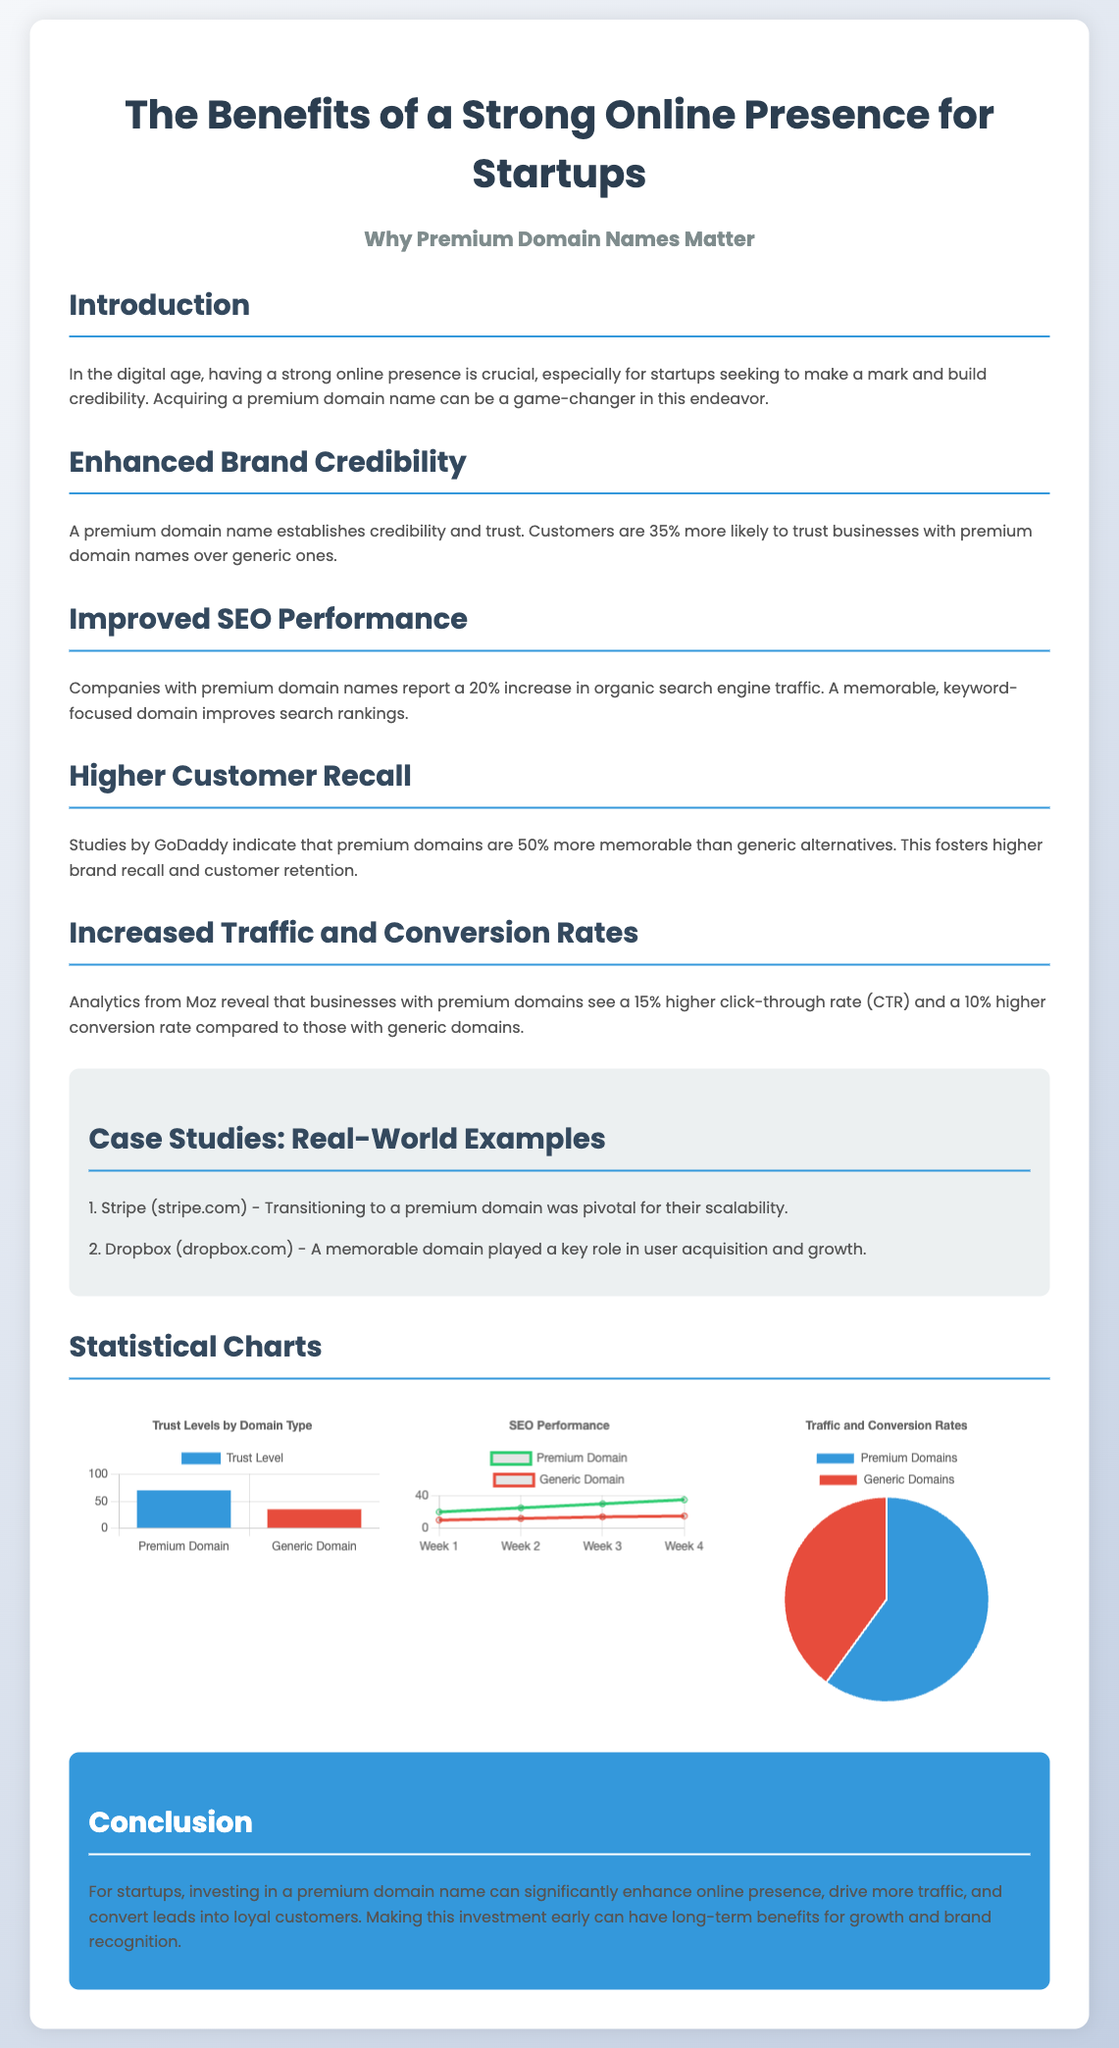What is the trust level for premium domains? The document states that customers are 35% more likely to trust businesses with premium domain names over generic ones, which indicates a trust level of 70% for premium domains.
Answer: 70% What is the trust level for generic domains? The trust level for generic domains is provided in the document as being 35%.
Answer: 35% What percentage increase in organic search engine traffic do premium domains report? The document mentions that companies with premium domain names report a 20% increase in organic search engine traffic.
Answer: 20% What were the SEO performance numbers for generic domains in Week 4? The data for generic domains in Week 4 is specified in the document as 15.
Answer: 15 What is the percentage difference in click-through rates between premium and generic domains? The document states that businesses with premium domains see a 15% higher click-through rate (CTR) compared to generic domains.
Answer: 15% What kind of chart is used to depict Traffic and Conversion Rates? The document specifies that a pie chart is used to illustrate Traffic and Conversion Rates between premium and generic domains.
Answer: Pie chart Which startup is mentioned as having a pivotal experience using a premium domain? The document lists Stripe as a startup that transitioned to a premium domain which was pivotal for their scalability.
Answer: Stripe What is the color representing generic domains in the trust level chart? The document identifies the color red (#e74c3c) as representing generic domains in the trust level chart.
Answer: Red Which section discusses higher customer recall? The section about "Higher Customer Recall" examines the memorability of premium domains relative to generic ones.
Answer: Higher Customer Recall 